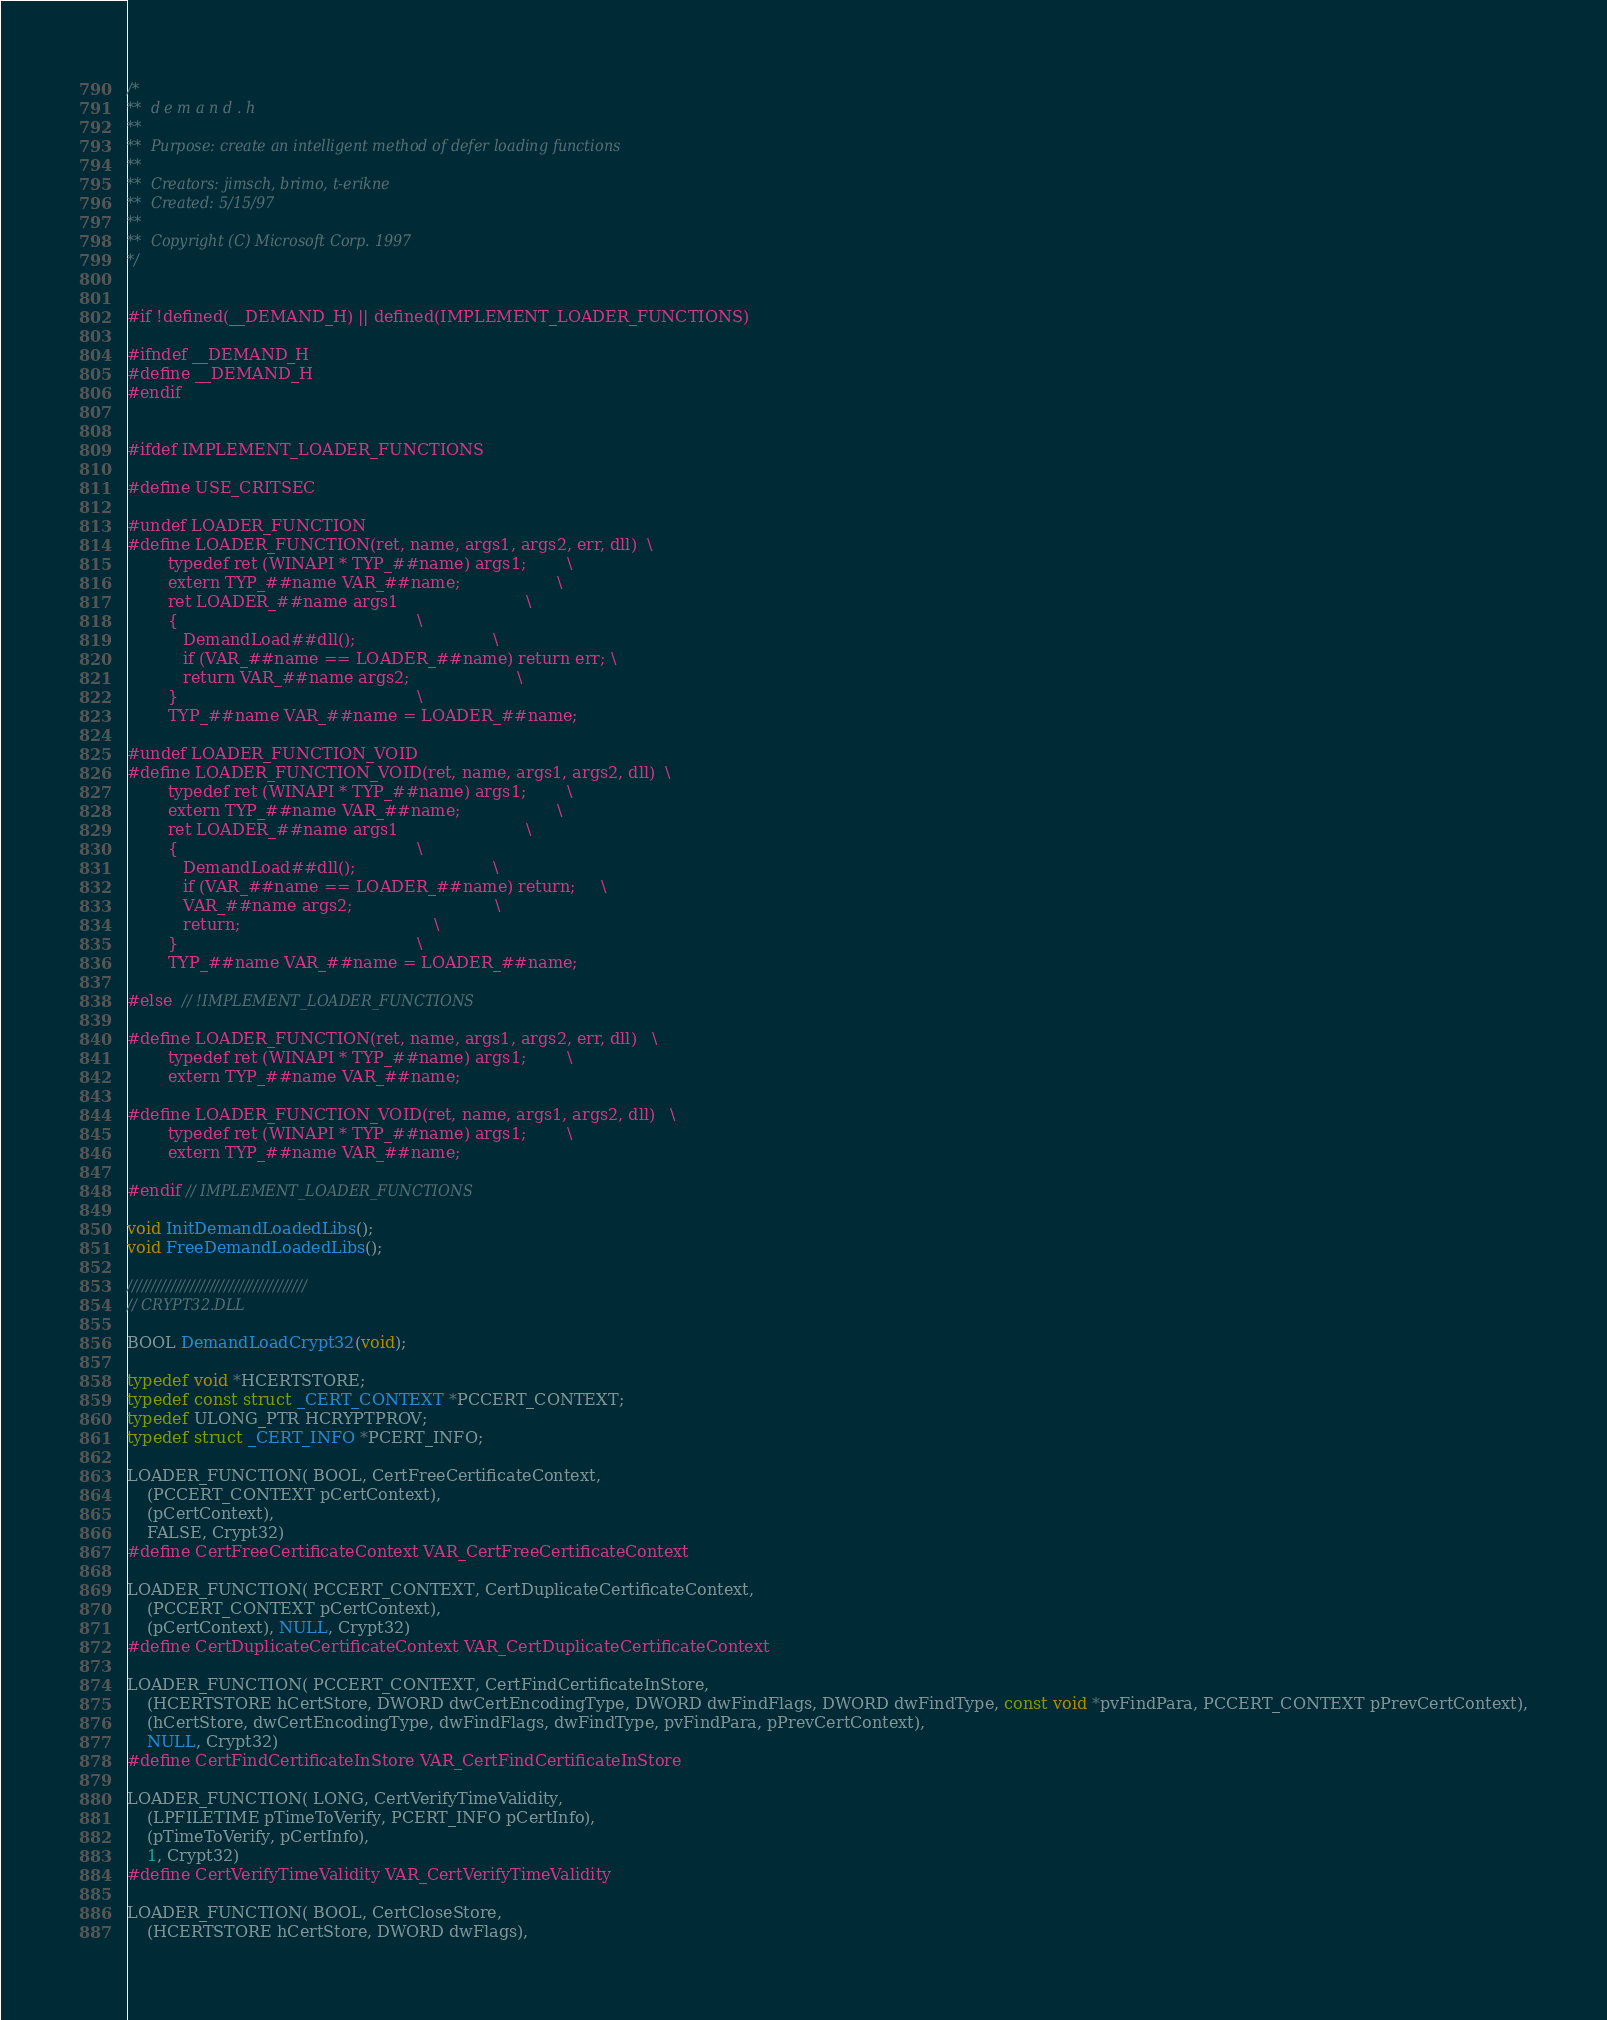<code> <loc_0><loc_0><loc_500><loc_500><_C_>/*
**	d e m a n d . h
**	
**	Purpose: create an intelligent method of defer loading functions
**
**  Creators: jimsch, brimo, t-erikne
**  Created: 5/15/97
**	
**	Copyright (C) Microsoft Corp. 1997
*/


#if !defined(__DEMAND_H) || defined(IMPLEMENT_LOADER_FUNCTIONS)

#ifndef __DEMAND_H
#define __DEMAND_H
#endif


#ifdef IMPLEMENT_LOADER_FUNCTIONS

#define USE_CRITSEC

#undef LOADER_FUNCTION
#define LOADER_FUNCTION(ret, name, args1, args2, err, dll)  \
        typedef ret (WINAPI * TYP_##name) args1;        \
        extern TYP_##name VAR_##name;                   \
        ret LOADER_##name args1                         \
        {                                               \
           DemandLoad##dll();                           \
           if (VAR_##name == LOADER_##name) return err; \
           return VAR_##name args2;                     \
        }                                               \
        TYP_##name VAR_##name = LOADER_##name;

#undef LOADER_FUNCTION_VOID
#define LOADER_FUNCTION_VOID(ret, name, args1, args2, dll)  \
        typedef ret (WINAPI * TYP_##name) args1;        \
        extern TYP_##name VAR_##name;                   \
        ret LOADER_##name args1                         \
        {                                               \
           DemandLoad##dll();                           \
           if (VAR_##name == LOADER_##name) return;     \
           VAR_##name args2;                            \
           return;                                      \
        }                                               \
        TYP_##name VAR_##name = LOADER_##name;

#else  // !IMPLEMENT_LOADER_FUNCTIONS

#define LOADER_FUNCTION(ret, name, args1, args2, err, dll)   \
        typedef ret (WINAPI * TYP_##name) args1;        \
        extern TYP_##name VAR_##name;

#define LOADER_FUNCTION_VOID(ret, name, args1, args2, dll)   \
        typedef ret (WINAPI * TYP_##name) args1;        \
        extern TYP_##name VAR_##name;

#endif // IMPLEMENT_LOADER_FUNCTIONS

void InitDemandLoadedLibs();
void FreeDemandLoadedLibs();

/////////////////////////////////////
// CRYPT32.DLL

BOOL DemandLoadCrypt32(void);

typedef void *HCERTSTORE;
typedef const struct _CERT_CONTEXT *PCCERT_CONTEXT;
typedef ULONG_PTR HCRYPTPROV;
typedef struct _CERT_INFO *PCERT_INFO;

LOADER_FUNCTION( BOOL, CertFreeCertificateContext,
    (PCCERT_CONTEXT pCertContext),
    (pCertContext),
    FALSE, Crypt32)
#define CertFreeCertificateContext VAR_CertFreeCertificateContext

LOADER_FUNCTION( PCCERT_CONTEXT, CertDuplicateCertificateContext,
    (PCCERT_CONTEXT pCertContext),
    (pCertContext), NULL, Crypt32)
#define CertDuplicateCertificateContext VAR_CertDuplicateCertificateContext

LOADER_FUNCTION( PCCERT_CONTEXT, CertFindCertificateInStore,
    (HCERTSTORE hCertStore, DWORD dwCertEncodingType, DWORD dwFindFlags, DWORD dwFindType, const void *pvFindPara, PCCERT_CONTEXT pPrevCertContext),
    (hCertStore, dwCertEncodingType, dwFindFlags, dwFindType, pvFindPara, pPrevCertContext),
    NULL, Crypt32)
#define CertFindCertificateInStore VAR_CertFindCertificateInStore

LOADER_FUNCTION( LONG, CertVerifyTimeValidity,
    (LPFILETIME pTimeToVerify, PCERT_INFO pCertInfo),
    (pTimeToVerify, pCertInfo),
    1, Crypt32)
#define CertVerifyTimeValidity VAR_CertVerifyTimeValidity

LOADER_FUNCTION( BOOL, CertCloseStore,
    (HCERTSTORE hCertStore, DWORD dwFlags),</code> 